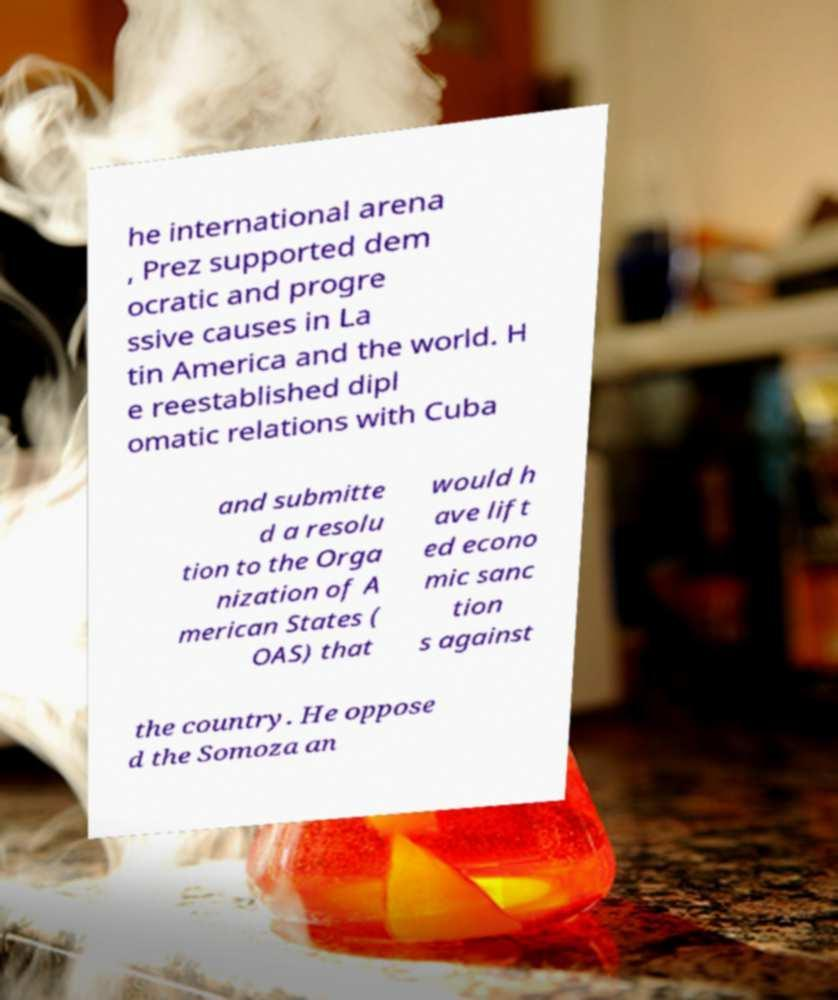What messages or text are displayed in this image? I need them in a readable, typed format. he international arena , Prez supported dem ocratic and progre ssive causes in La tin America and the world. H e reestablished dipl omatic relations with Cuba and submitte d a resolu tion to the Orga nization of A merican States ( OAS) that would h ave lift ed econo mic sanc tion s against the country. He oppose d the Somoza an 